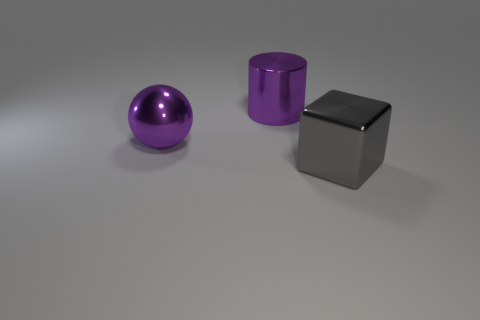How many tiny objects are purple shiny balls or purple shiny objects?
Your response must be concise. 0. Are there more purple metallic cylinders right of the metallic sphere than big gray metallic cubes that are in front of the shiny block?
Offer a terse response. Yes. Do the large ball and the large cube in front of the big purple cylinder have the same material?
Your response must be concise. Yes. What is the color of the shiny ball?
Your answer should be very brief. Purple. What shape is the large purple thing in front of the large cylinder?
Your response must be concise. Sphere. What number of blue objects are either large rubber cubes or large blocks?
Ensure brevity in your answer.  0. What is the color of the big cylinder that is made of the same material as the large gray object?
Offer a very short reply. Purple. Does the big ball have the same color as the big metal thing that is on the right side of the large purple cylinder?
Keep it short and to the point. No. There is a large shiny thing that is both to the right of the big purple metal sphere and left of the large metal cube; what color is it?
Make the answer very short. Purple. There is a gray cube; what number of metallic things are in front of it?
Your answer should be very brief. 0. 